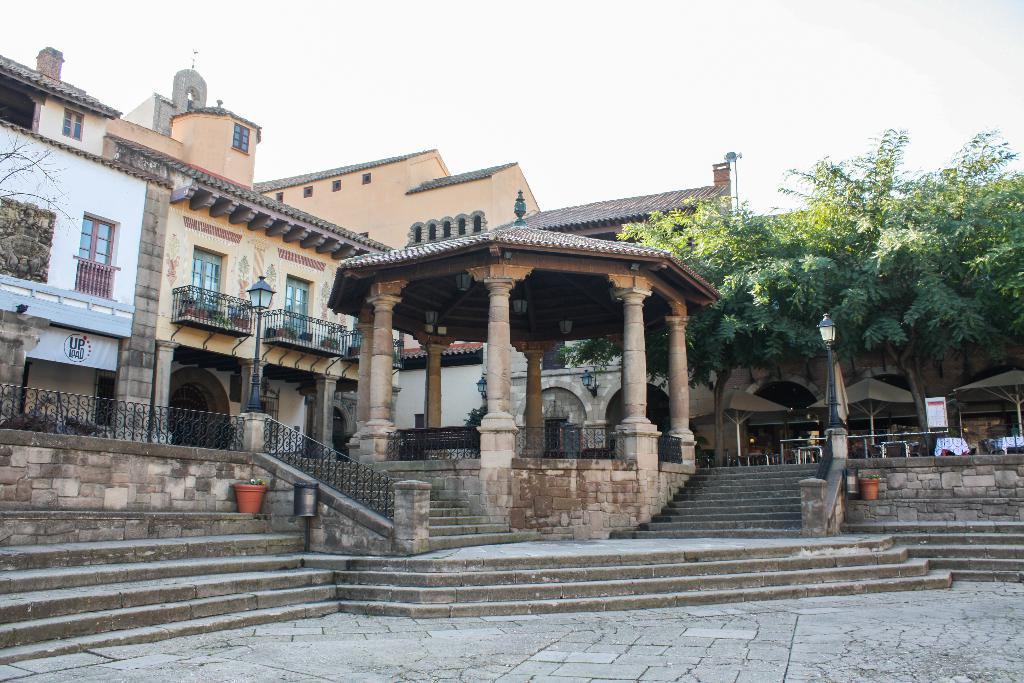Can you describe this image briefly? In this image I can see in the middle there is the building and there are staircases. On the right side there are trees, at the top it is the cloudy sky. 